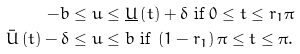<formula> <loc_0><loc_0><loc_500><loc_500>- b & \leq u \leq \underline { U } \left ( t \right ) + \delta \text { if } 0 \leq t \leq r _ { 1 } \pi \\ \bar { U } \left ( t \right ) - \delta & \leq u \leq b \text { if } \left ( 1 - r _ { 1 } \right ) \pi \leq t \leq \pi .</formula> 